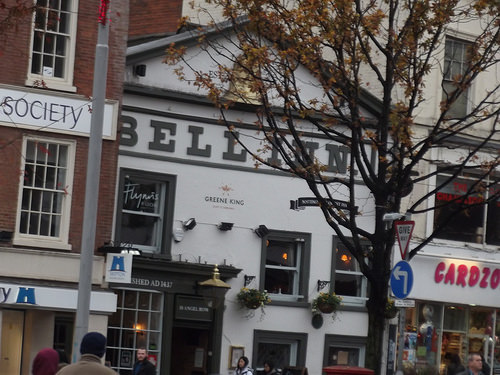<image>
Is the building in front of the tree? Yes. The building is positioned in front of the tree, appearing closer to the camera viewpoint. 